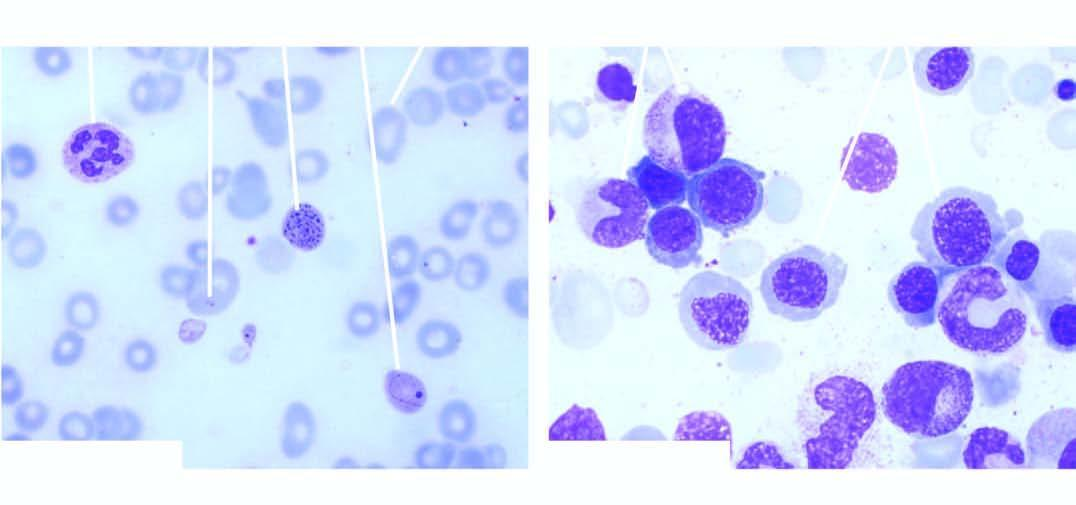does a scar smaller than the original wound aspirate show megaloblastic erythropoiesis?
Answer the question using a single word or phrase. No 